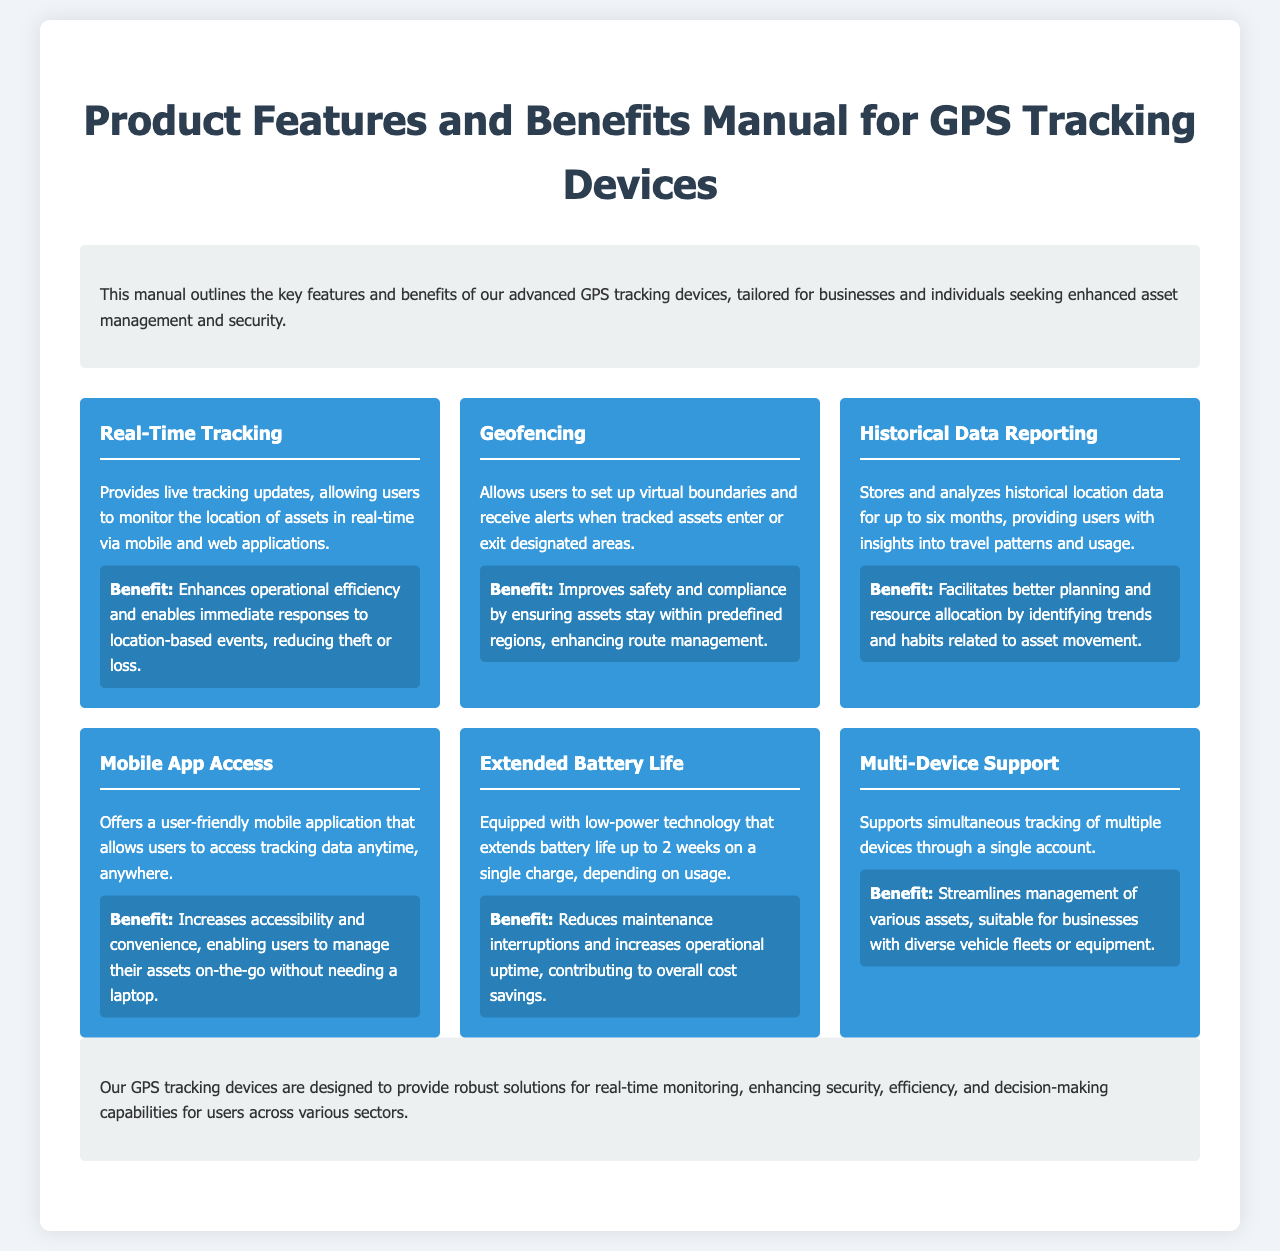What is the title of the manual? The title of the manual is stated clearly at the beginning of the document.
Answer: Product Features and Benefits Manual for GPS Tracking Devices What feature allows users to receive alerts for asset location changes? The feature designed for monitoring changes in asset location through alerts is specified in the features section.
Answer: Geofencing How long can historical location data be stored? The document specifies the duration for which historical location data can be stored.
Answer: Six months What is the benefit of real-time tracking? The benefit associated with real-time tracking is given under its respective feature description.
Answer: Enhances operational efficiency What is the maximum battery life of the devices? The maximum duration for which the devices can operate on a single charge is mentioned in the document.
Answer: Two weeks How many devices can be supported simultaneously? The document outlines the capability related to managing multiple devices.
Answer: Multiple devices What is the primary audience for these GPS tracking devices? The intended primary audience for the GPS tracking devices is described in the introduction section.
Answer: Businesses and individuals What does the mobile app provide access to? The features of the mobile app highlight what users can access through it.
Answer: Tracking data What color is used for the benefit background? The document specifies the color scheme used in the benefits section.
Answer: Blue 